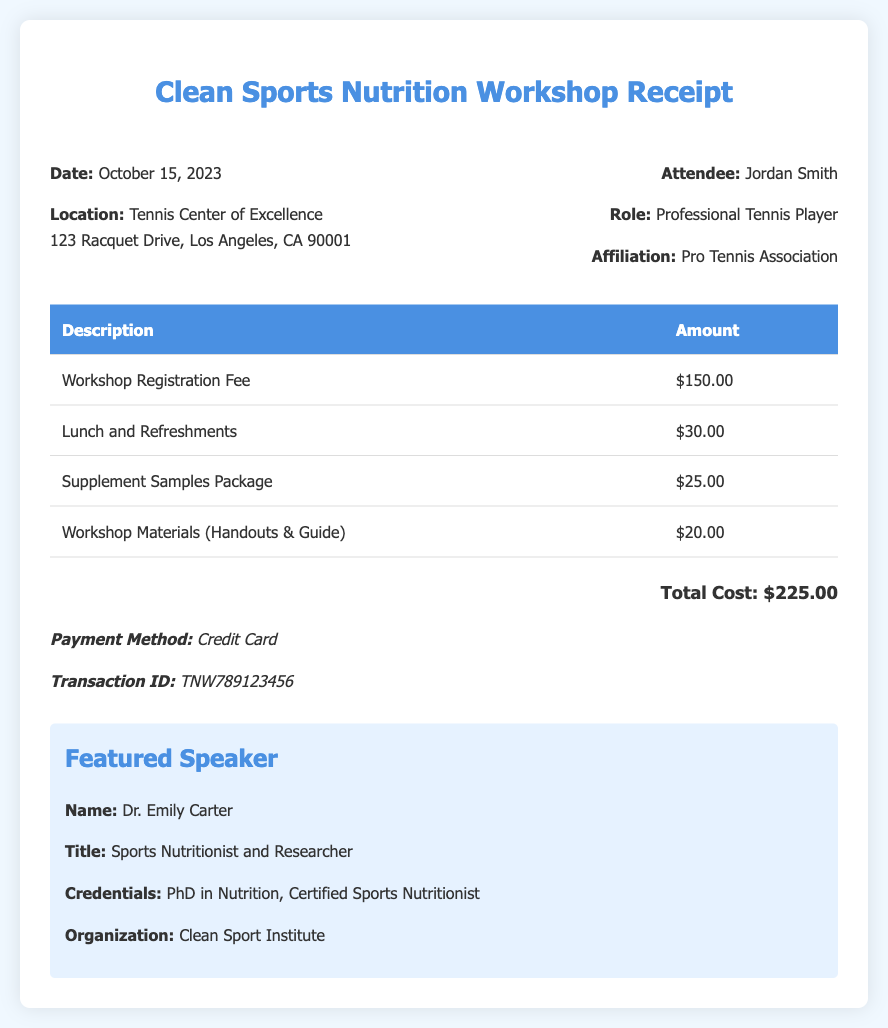what is the date of the workshop? The date of the workshop is clearly stated in the document.
Answer: October 15, 2023 what is the total cost of attending the workshop? The total cost is the sum of the itemized costs listed in the receipt.
Answer: $225.00 who is the featured speaker at the workshop? The name of the featured speaker is provided in the speaker information section.
Answer: Dr. Emily Carter what was the payment method used for the workshop? The payment method is explicitly mentioned in the payment information section.
Answer: Credit Card how much did the lunch and refreshments cost? The specific cost for lunch and refreshments is detailed in the itemized costs.
Answer: $30.00 what organization is Dr. Emily Carter associated with? The organization is mentioned in the speaker information.
Answer: Clean Sport Institute what is the transaction ID for the payment? The transaction ID is given in the payment information section.
Answer: TNW789123456 how much did the workshop registration fee cost? The cost for the workshop registration fee is listed in the itemized expenses.
Answer: $150.00 what role does Jordan Smith have? The role of the attendee is specified in the attendee details section.
Answer: Professional Tennis Player 